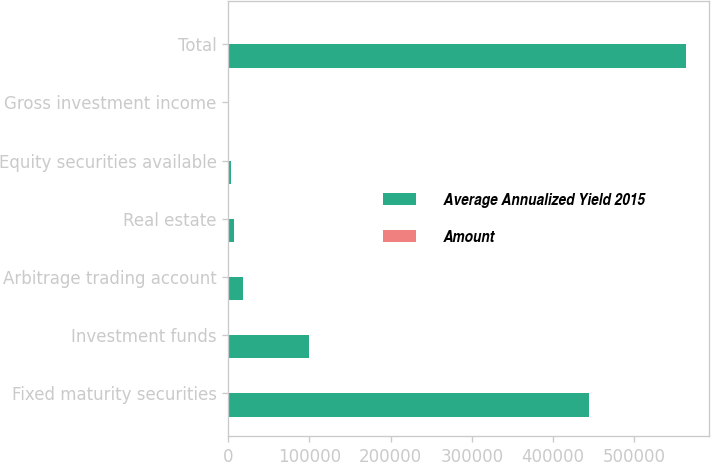Convert chart to OTSL. <chart><loc_0><loc_0><loc_500><loc_500><stacked_bar_chart><ecel><fcel>Fixed maturity securities<fcel>Investment funds<fcel>Arbitrage trading account<fcel>Real estate<fcel>Equity securities available<fcel>Gross investment income<fcel>Total<nl><fcel>Average Annualized Yield 2015<fcel>444247<fcel>99301<fcel>18693<fcel>7054<fcel>4028<fcel>8.1<fcel>564163<nl><fcel>Amount<fcel>3.2<fcel>8.1<fcel>4.8<fcel>0.7<fcel>2.1<fcel>3.4<fcel>3.4<nl></chart> 